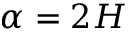Convert formula to latex. <formula><loc_0><loc_0><loc_500><loc_500>\alpha = 2 H</formula> 